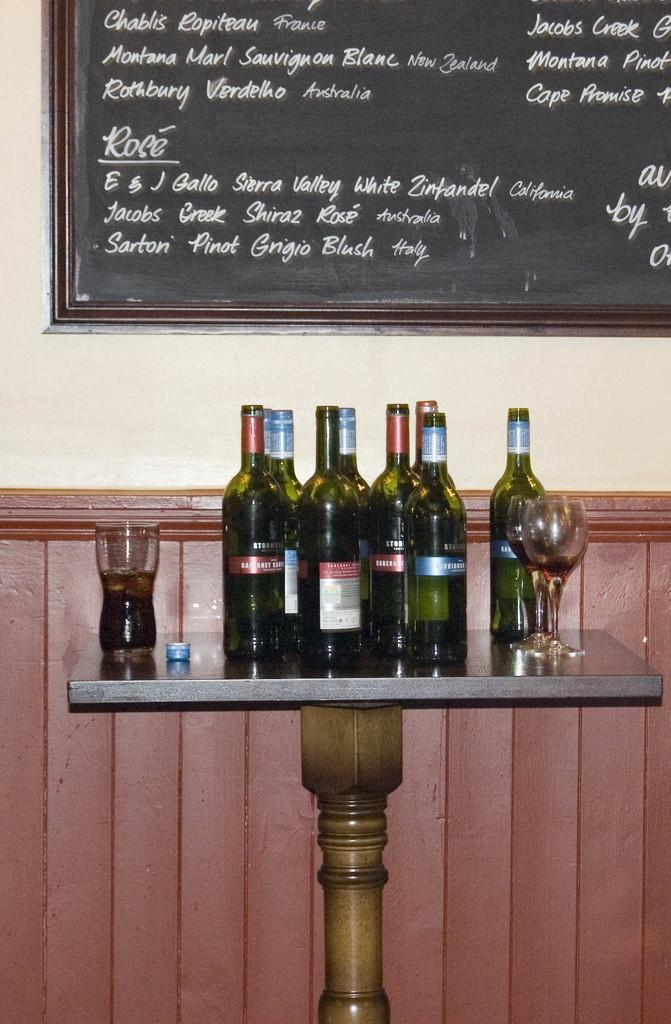<image>
Give a short and clear explanation of the subsequent image. Jacobs and Montana are amongst the many names written on the chalkboard. 